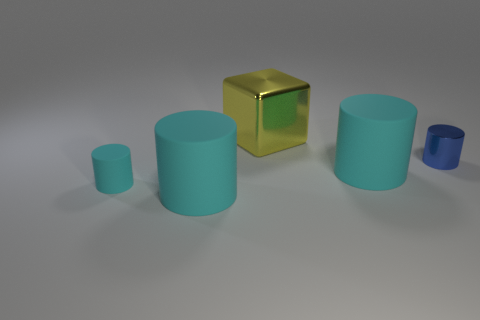What is the shape of the thing that is right of the tiny cyan matte thing and on the left side of the yellow metal thing?
Make the answer very short. Cylinder. What number of other things are there of the same color as the tiny metal cylinder?
Keep it short and to the point. 0. What is the shape of the blue object?
Keep it short and to the point. Cylinder. What color is the big rubber cylinder that is behind the big matte thing that is to the left of the large shiny block?
Offer a very short reply. Cyan. Is the color of the cube the same as the large cylinder that is on the left side of the yellow cube?
Your answer should be very brief. No. What is the material of the big object that is both behind the small cyan matte cylinder and in front of the shiny cube?
Give a very brief answer. Rubber. Are there any green metal blocks of the same size as the yellow metallic thing?
Provide a succinct answer. No. There is a cyan object that is the same size as the blue object; what is it made of?
Ensure brevity in your answer.  Rubber. How many big cyan rubber things are on the left side of the blue object?
Keep it short and to the point. 2. Is the shape of the rubber object that is on the right side of the big yellow cube the same as  the yellow thing?
Your answer should be very brief. No. 